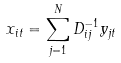<formula> <loc_0><loc_0><loc_500><loc_500>x _ { i t } = \sum _ { j = 1 } ^ { N } D ^ { - 1 } _ { i j } y _ { j t }</formula> 